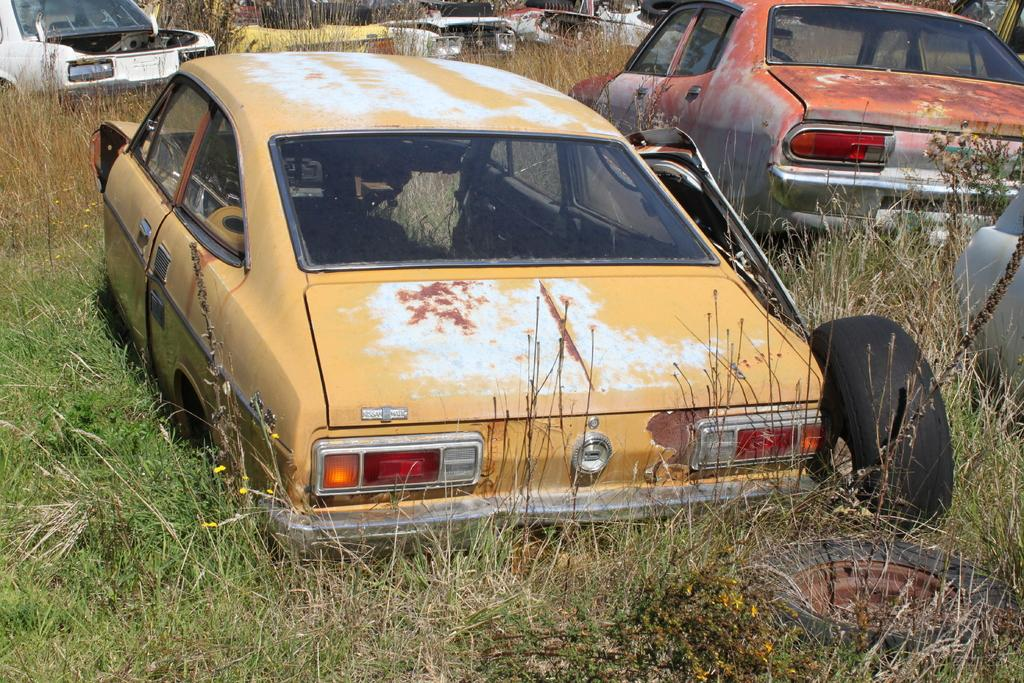What is the main subject of the image? The main subject of the image is many vehicles. Can you describe one of the vehicles in the image? One of the vehicles is yellow. What color is the wheel mentioned in the image? There is a black wheel in the image. How would you describe the grass in the image? The grass has brown and green colors. How many units of steel can be seen in the image? There is no steel present in the image. What type of clothing are the women wearing in the image? There are no women present in the image. 